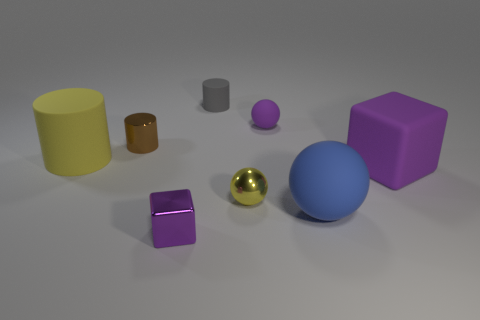What number of objects are behind the brown object and to the left of the small yellow object?
Your answer should be compact. 1. The thing to the right of the big blue rubber ball has what shape?
Make the answer very short. Cube. What number of tiny purple spheres are the same material as the blue thing?
Provide a succinct answer. 1. Is the shape of the blue thing the same as the shiny thing on the right side of the tiny purple shiny object?
Keep it short and to the point. Yes. Are there any small things that are in front of the tiny purple object to the right of the tiny metallic thing in front of the big blue matte ball?
Your response must be concise. Yes. What size is the metallic thing behind the large matte cube?
Provide a succinct answer. Small. There is a gray thing that is the same size as the yellow metallic object; what material is it?
Keep it short and to the point. Rubber. Is the large blue rubber thing the same shape as the small yellow metallic object?
Give a very brief answer. Yes. What number of things are either large spheres or large matte cubes that are right of the tiny yellow thing?
Provide a succinct answer. 2. What is the material of the small ball that is the same color as the big rubber block?
Keep it short and to the point. Rubber. 